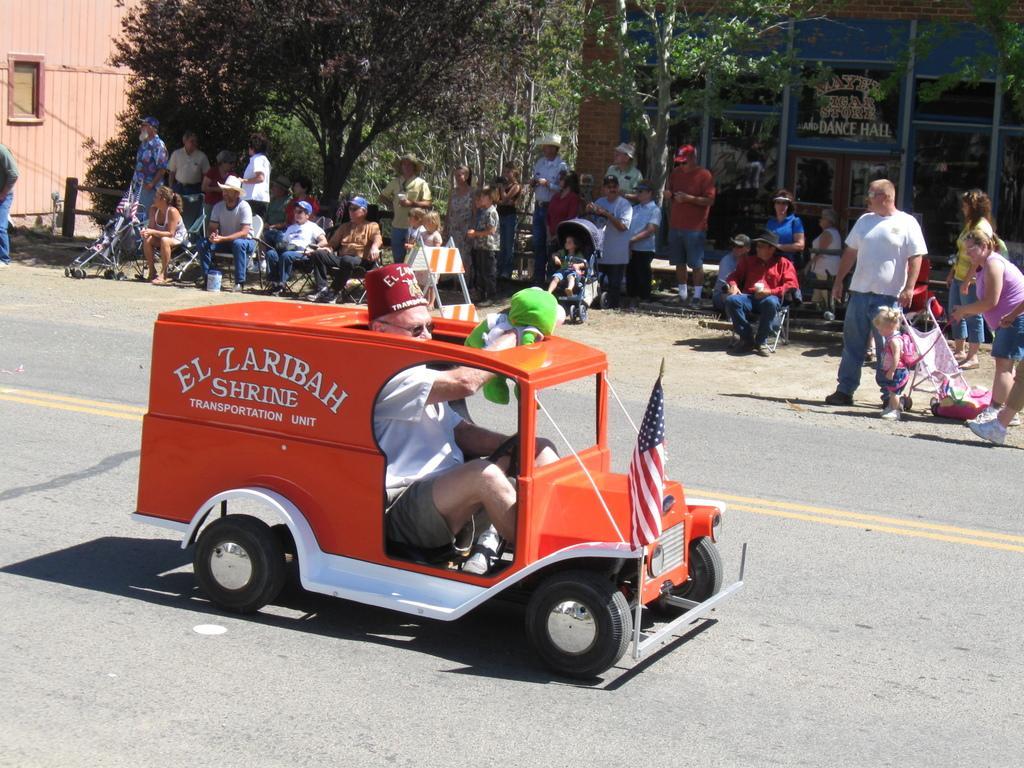Please provide a concise description of this image. I can see a person driving a mini car. This is the flag hanging to the pole. I can see few people sitting and few people standing. Here is a baby sitting in the stroller. These are the trees. This looks like a building with the glass doors. I can see another stroller here. 